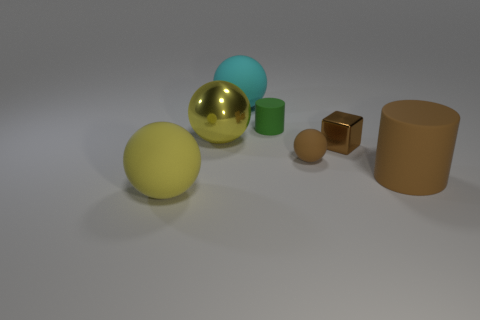There is a yellow object on the right side of the yellow rubber ball; does it have the same size as the green object?
Your answer should be very brief. No. How many other things are the same size as the cyan matte ball?
Provide a short and direct response. 3. Are any small red metallic objects visible?
Give a very brief answer. No. There is a cylinder that is in front of the ball that is right of the cyan thing; what size is it?
Give a very brief answer. Large. There is a sphere on the right side of the cyan matte sphere; is its color the same as the cylinder that is to the right of the green thing?
Your response must be concise. Yes. What is the color of the rubber ball that is in front of the small brown shiny thing and behind the brown rubber cylinder?
Keep it short and to the point. Brown. What number of other objects are the same shape as the big brown matte object?
Keep it short and to the point. 1. The ball that is the same size as the brown cube is what color?
Give a very brief answer. Brown. There is a metal object left of the cyan sphere; what is its color?
Offer a very short reply. Yellow. There is a big rubber object that is right of the cyan matte ball; is there a yellow matte sphere that is on the right side of it?
Ensure brevity in your answer.  No. 